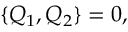<formula> <loc_0><loc_0><loc_500><loc_500>\{ Q _ { 1 } , Q _ { 2 } \} = 0 ,</formula> 